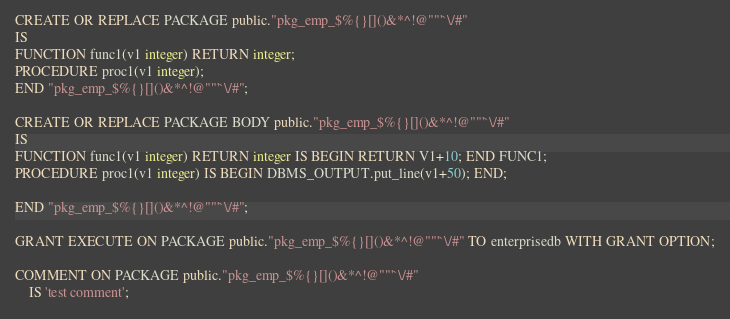Convert code to text. <code><loc_0><loc_0><loc_500><loc_500><_SQL_>CREATE OR REPLACE PACKAGE public."pkg_emp_$%{}[]()&*^!@""'`\/#"
IS
FUNCTION func1(v1 integer) RETURN integer;
PROCEDURE proc1(v1 integer);
END "pkg_emp_$%{}[]()&*^!@""'`\/#";

CREATE OR REPLACE PACKAGE BODY public."pkg_emp_$%{}[]()&*^!@""'`\/#"
IS
FUNCTION func1(v1 integer) RETURN integer IS BEGIN RETURN V1+10; END FUNC1;
PROCEDURE proc1(v1 integer) IS BEGIN DBMS_OUTPUT.put_line(v1+50); END;

END "pkg_emp_$%{}[]()&*^!@""'`\/#";

GRANT EXECUTE ON PACKAGE public."pkg_emp_$%{}[]()&*^!@""'`\/#" TO enterprisedb WITH GRANT OPTION;

COMMENT ON PACKAGE public."pkg_emp_$%{}[]()&*^!@""'`\/#"
    IS 'test comment';
</code> 